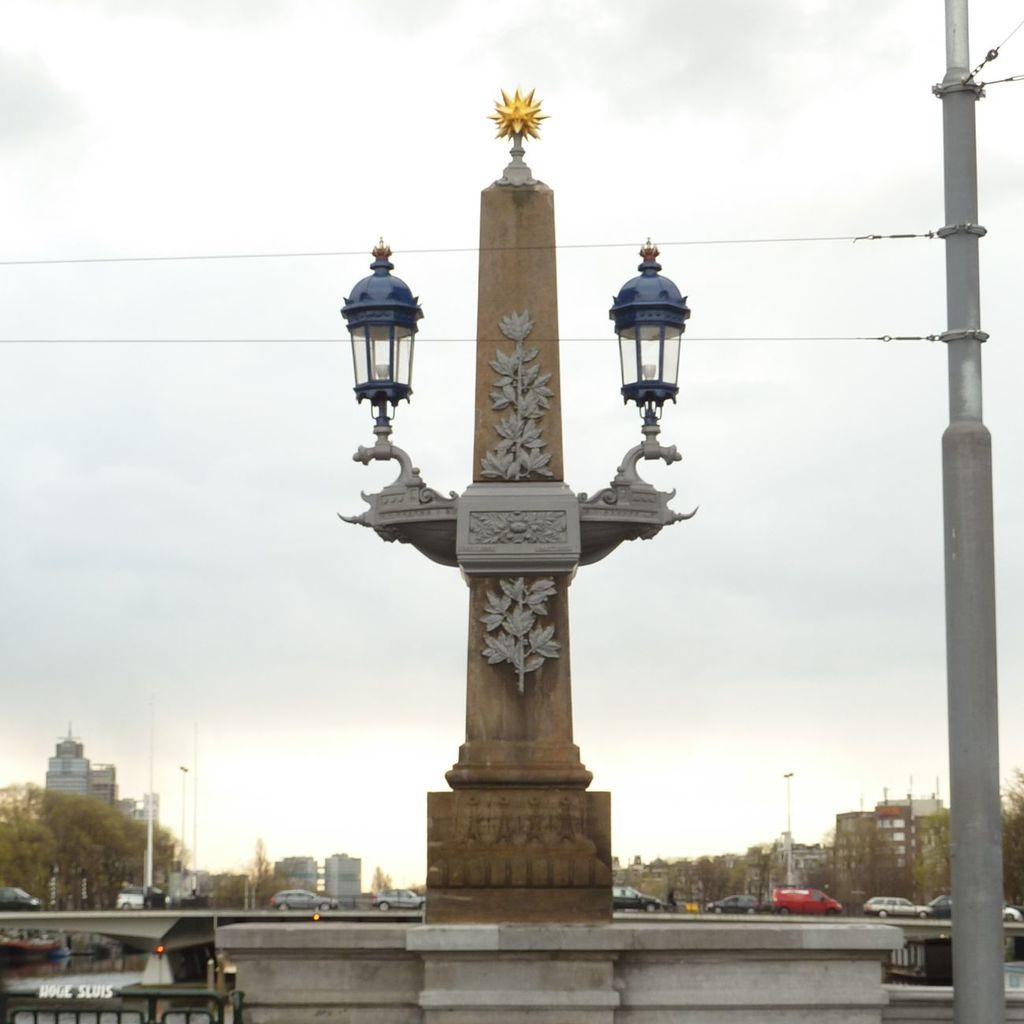What is the main structure in the image? There is a pillar with lights in the image. What can be seen behind the pillar? Vehicles are visible behind the pillar. What type of natural elements are present in the image? There are trees in the image. What type of man-made structures can be seen in the image? There are buildings in the image. What is visible in the sky in the image? The sky is visible in the image. What is located on the right side of the image? There is a pole with cables on the right side of the image. How many records can be seen in the image? There are no records present in the image. What type of care is being provided to the trees in the image? There is no indication of care being provided to the trees in the image; they are simply visible. 